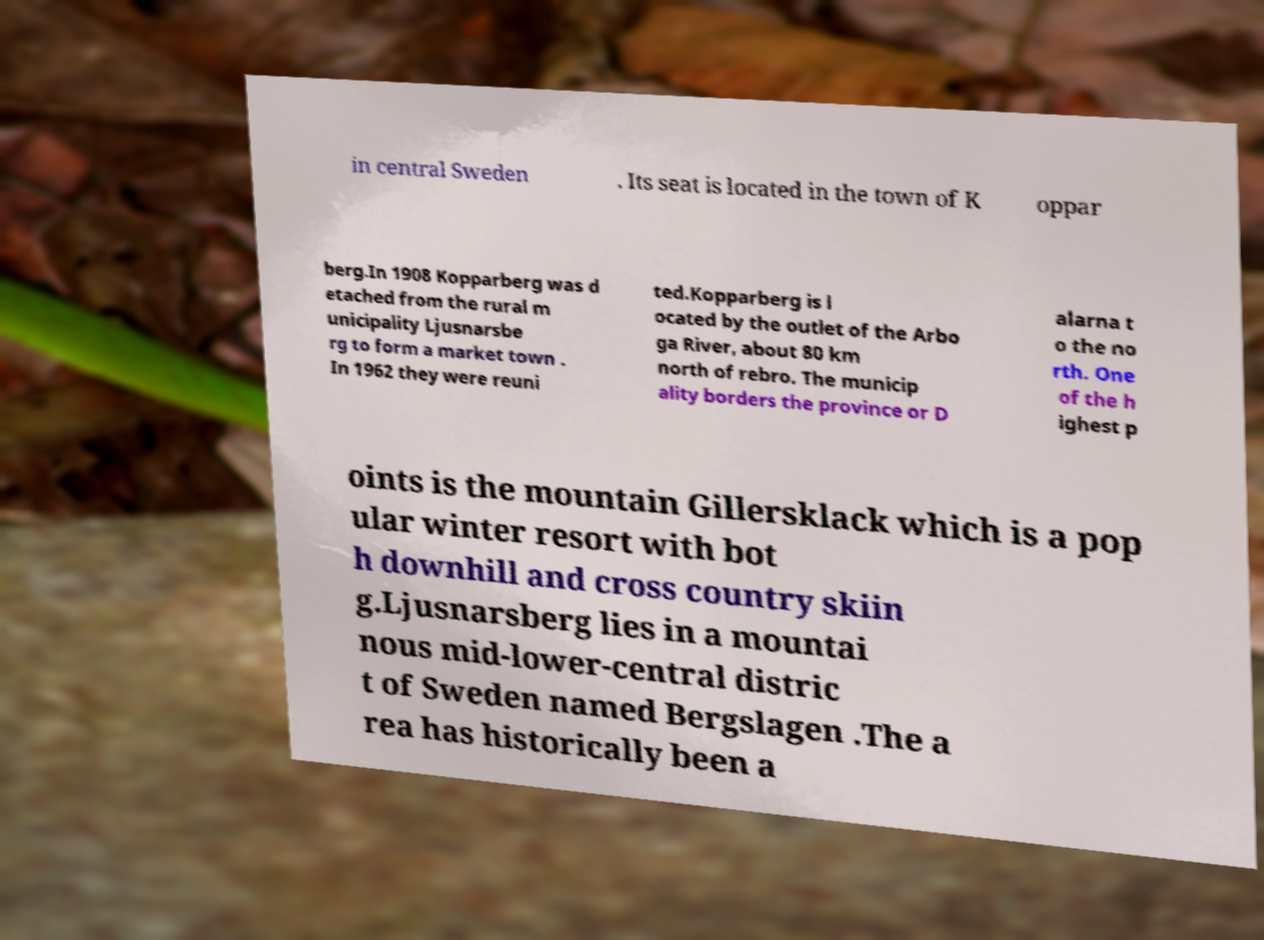I need the written content from this picture converted into text. Can you do that? in central Sweden . Its seat is located in the town of K oppar berg.In 1908 Kopparberg was d etached from the rural m unicipality Ljusnarsbe rg to form a market town . In 1962 they were reuni ted.Kopparberg is l ocated by the outlet of the Arbo ga River, about 80 km north of rebro. The municip ality borders the province or D alarna t o the no rth. One of the h ighest p oints is the mountain Gillersklack which is a pop ular winter resort with bot h downhill and cross country skiin g.Ljusnarsberg lies in a mountai nous mid-lower-central distric t of Sweden named Bergslagen .The a rea has historically been a 